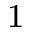Convert formula to latex. <formula><loc_0><loc_0><loc_500><loc_500>_ { 1 }</formula> 